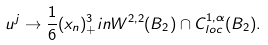Convert formula to latex. <formula><loc_0><loc_0><loc_500><loc_500>u ^ { j } \rightarrow \frac { 1 } { 6 } ( x _ { n } ) _ { + } ^ { 3 } i n W ^ { 2 , 2 } ( B _ { 2 } ) \cap C _ { l o c } ^ { 1 , \alpha } ( B _ { 2 } ) .</formula> 